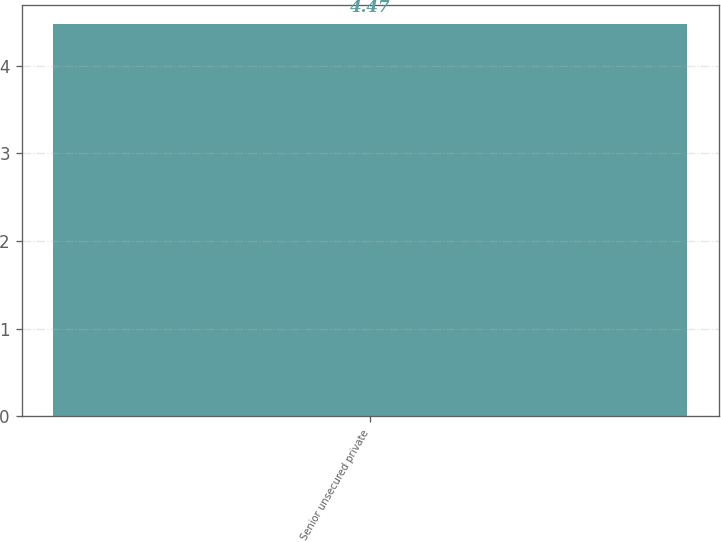Convert chart to OTSL. <chart><loc_0><loc_0><loc_500><loc_500><bar_chart><fcel>Senior unsecured private<nl><fcel>4.47<nl></chart> 